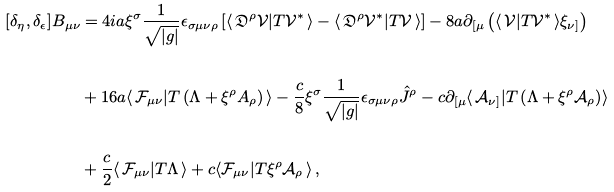Convert formula to latex. <formula><loc_0><loc_0><loc_500><loc_500>[ \delta _ { \eta } , \delta _ { \epsilon } ] B _ { \mu \nu } & = 4 i a \xi ^ { \sigma } \frac { 1 } { \sqrt { | g | } } \epsilon _ { \sigma \mu \nu \rho } \left [ \langle \, \mathfrak { D } ^ { \rho } \mathcal { V } | T \mathcal { V } ^ { * } \, \rangle - \langle \, \mathfrak { D } ^ { \rho } \mathcal { V } ^ { * } | T \mathcal { V } \, \rangle \right ] - 8 a \partial _ { [ \mu } \left ( \langle \, \mathcal { V } | T \mathcal { V } ^ { * } \, \rangle \xi _ { \nu ] } \right ) \\ & \\ & + 1 6 a \langle \, \mathcal { F } _ { \mu \nu } | T \left ( \Lambda + \xi ^ { \rho } A _ { \rho } \right ) \, \rangle - \frac { c } { 8 } \xi ^ { \sigma } \frac { 1 } { \sqrt { | g | } } \epsilon _ { \sigma \mu \nu \rho } \hat { J } ^ { \rho } - c \partial _ { [ \mu } \langle \, \mathcal { A } _ { \nu ] } | T \left ( \Lambda + \xi ^ { \rho } \mathcal { A } _ { \rho } \right ) \rangle \\ & \\ & + \frac { c } { 2 } \langle \, \mathcal { F } _ { \mu \nu } | T \Lambda \, \rangle + c \langle \mathcal { F } _ { \mu \nu } | T \xi ^ { \rho } \mathcal { A } _ { \rho } \, \rangle \, ,</formula> 